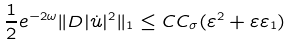Convert formula to latex. <formula><loc_0><loc_0><loc_500><loc_500>\frac { 1 } { 2 } e ^ { - 2 \omega } \| D | \dot { u } | ^ { 2 } \| _ { 1 } \leq C C _ { \sigma } ( \varepsilon ^ { 2 } + \varepsilon \varepsilon _ { 1 } )</formula> 